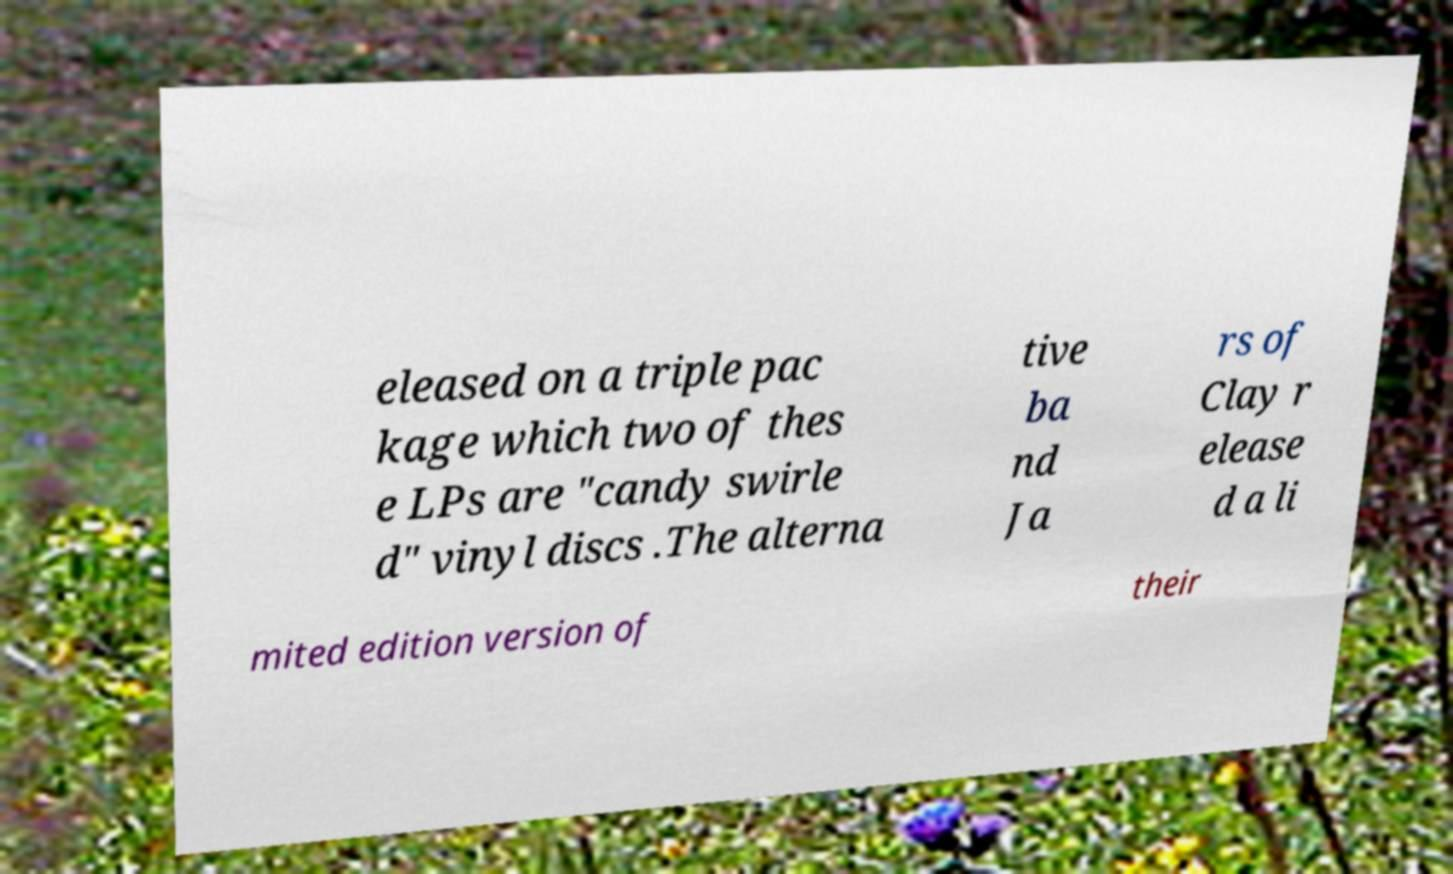Could you extract and type out the text from this image? eleased on a triple pac kage which two of thes e LPs are "candy swirle d" vinyl discs .The alterna tive ba nd Ja rs of Clay r elease d a li mited edition version of their 